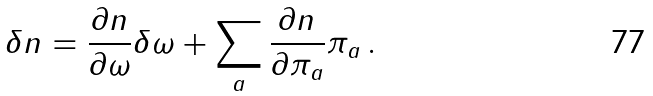<formula> <loc_0><loc_0><loc_500><loc_500>\delta n = \frac { \partial n } { \partial \omega } \delta \omega + \sum _ { a } \frac { \partial n } { \partial \pi _ { a } } \pi _ { a } \, .</formula> 